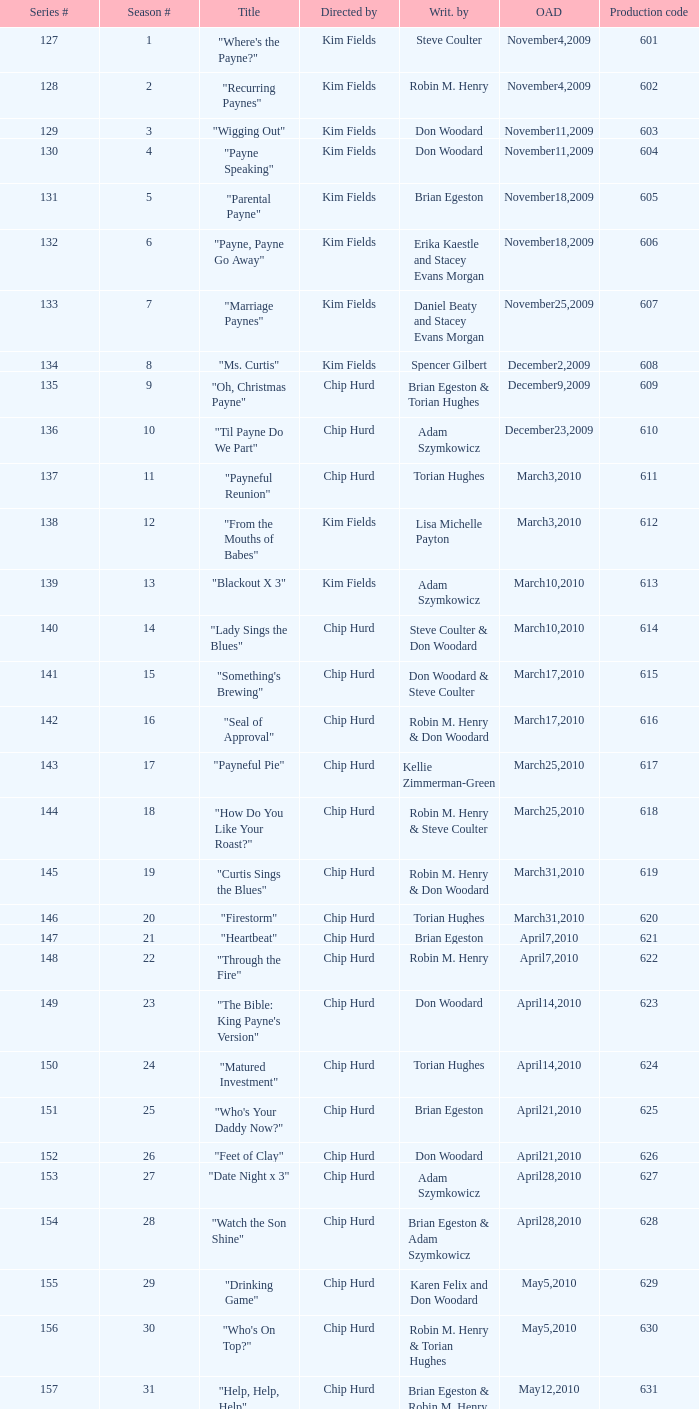Could you parse the entire table? {'header': ['Series #', 'Season #', 'Title', 'Directed by', 'Writ. by', 'OAD', 'Production code'], 'rows': [['127', '1', '"Where\'s the Payne?"', 'Kim Fields', 'Steve Coulter', 'November4,2009', '601'], ['128', '2', '"Recurring Paynes"', 'Kim Fields', 'Robin M. Henry', 'November4,2009', '602'], ['129', '3', '"Wigging Out"', 'Kim Fields', 'Don Woodard', 'November11,2009', '603'], ['130', '4', '"Payne Speaking"', 'Kim Fields', 'Don Woodard', 'November11,2009', '604'], ['131', '5', '"Parental Payne"', 'Kim Fields', 'Brian Egeston', 'November18,2009', '605'], ['132', '6', '"Payne, Payne Go Away"', 'Kim Fields', 'Erika Kaestle and Stacey Evans Morgan', 'November18,2009', '606'], ['133', '7', '"Marriage Paynes"', 'Kim Fields', 'Daniel Beaty and Stacey Evans Morgan', 'November25,2009', '607'], ['134', '8', '"Ms. Curtis"', 'Kim Fields', 'Spencer Gilbert', 'December2,2009', '608'], ['135', '9', '"Oh, Christmas Payne"', 'Chip Hurd', 'Brian Egeston & Torian Hughes', 'December9,2009', '609'], ['136', '10', '"Til Payne Do We Part"', 'Chip Hurd', 'Adam Szymkowicz', 'December23,2009', '610'], ['137', '11', '"Payneful Reunion"', 'Chip Hurd', 'Torian Hughes', 'March3,2010', '611'], ['138', '12', '"From the Mouths of Babes"', 'Kim Fields', 'Lisa Michelle Payton', 'March3,2010', '612'], ['139', '13', '"Blackout X 3"', 'Kim Fields', 'Adam Szymkowicz', 'March10,2010', '613'], ['140', '14', '"Lady Sings the Blues"', 'Chip Hurd', 'Steve Coulter & Don Woodard', 'March10,2010', '614'], ['141', '15', '"Something\'s Brewing"', 'Chip Hurd', 'Don Woodard & Steve Coulter', 'March17,2010', '615'], ['142', '16', '"Seal of Approval"', 'Chip Hurd', 'Robin M. Henry & Don Woodard', 'March17,2010', '616'], ['143', '17', '"Payneful Pie"', 'Chip Hurd', 'Kellie Zimmerman-Green', 'March25,2010', '617'], ['144', '18', '"How Do You Like Your Roast?"', 'Chip Hurd', 'Robin M. Henry & Steve Coulter', 'March25,2010', '618'], ['145', '19', '"Curtis Sings the Blues"', 'Chip Hurd', 'Robin M. Henry & Don Woodard', 'March31,2010', '619'], ['146', '20', '"Firestorm"', 'Chip Hurd', 'Torian Hughes', 'March31,2010', '620'], ['147', '21', '"Heartbeat"', 'Chip Hurd', 'Brian Egeston', 'April7,2010', '621'], ['148', '22', '"Through the Fire"', 'Chip Hurd', 'Robin M. Henry', 'April7,2010', '622'], ['149', '23', '"The Bible: King Payne\'s Version"', 'Chip Hurd', 'Don Woodard', 'April14,2010', '623'], ['150', '24', '"Matured Investment"', 'Chip Hurd', 'Torian Hughes', 'April14,2010', '624'], ['151', '25', '"Who\'s Your Daddy Now?"', 'Chip Hurd', 'Brian Egeston', 'April21,2010', '625'], ['152', '26', '"Feet of Clay"', 'Chip Hurd', 'Don Woodard', 'April21,2010', '626'], ['153', '27', '"Date Night x 3"', 'Chip Hurd', 'Adam Szymkowicz', 'April28,2010', '627'], ['154', '28', '"Watch the Son Shine"', 'Chip Hurd', 'Brian Egeston & Adam Szymkowicz', 'April28,2010', '628'], ['155', '29', '"Drinking Game"', 'Chip Hurd', 'Karen Felix and Don Woodard', 'May5,2010', '629'], ['156', '30', '"Who\'s On Top?"', 'Chip Hurd', 'Robin M. Henry & Torian Hughes', 'May5,2010', '630'], ['157', '31', '"Help, Help, Help"', 'Chip Hurd', 'Brian Egeston & Robin M. Henry', 'May12,2010', '631'], ['158', '32', '"Stinging Payne"', 'Chip Hurd', 'Don Woodard', 'May12,2010', '632'], ['159', '33', '"Worth Fighting For"', 'Chip Hurd', 'Torian Hughes', 'May19,2010', '633'], ['160', '34', '"Who\'s Your Nanny?"', 'Chip Hurd', 'Robin M. Henry & Adam Szymkowicz', 'May19,2010', '634'], ['161', '35', '"The Chef"', 'Chip Hurd', 'Anthony C. Hill', 'May26,2010', '635'], ['162', '36', '"My Fair Curtis"', 'Chip Hurd', 'Don Woodard', 'May26,2010', '636'], ['163', '37', '"Rest for the Weary"', 'Chip Hurd', 'Brian Egeston', 'June2,2010', '637'], ['164', '38', '"Thug Life"', 'Chip Hurd', 'Torian Hughes', 'June2,2010', '638'], ['165', '39', '"Rehabilitation"', 'Chip Hurd', 'Adam Szymkowicz', 'June9,2010', '639'], ['166', '40', '"A Payne In Need Is A Pain Indeed"', 'Chip Hurd', 'Don Woodard', 'June9,2010', '640'], ['167', '41', '"House Guest"', 'Chip Hurd', 'David A. Arnold', 'January5,2011', '641'], ['168', '42', '"Payne Showers"', 'Chip Hurd', 'Omega Mariaunnie Stewart and Torian Hughes', 'January5,2011', '642'], ['169', '43', '"Playing With Fire"', 'Chip Hurd', 'Carlos Portugal', 'January12,2011', '643'], ['170', '44', '"When the Payne\'s Away"', 'Chip Hurd', 'Kristin Topps and Don Woodard', 'January12,2011', '644'], ['171', '45', '"Beginnings"', 'Chip Hurd', 'Myra J.', 'January19,2011', '645']]} What is the original air date of the episode written by Karen Felix and Don Woodard? May5,2010. 